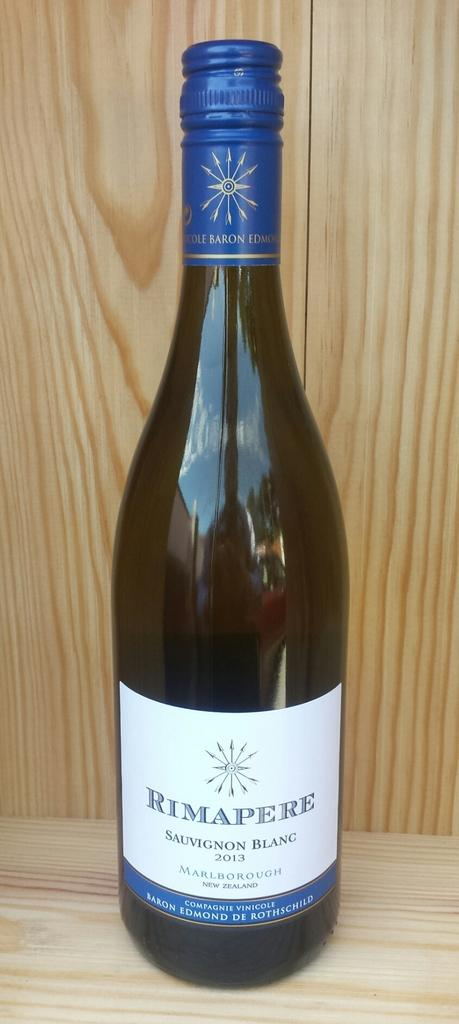<image>
Share a concise interpretation of the image provided. A bottle of Rimapere sauvignon blanc 2013 on a wood background 